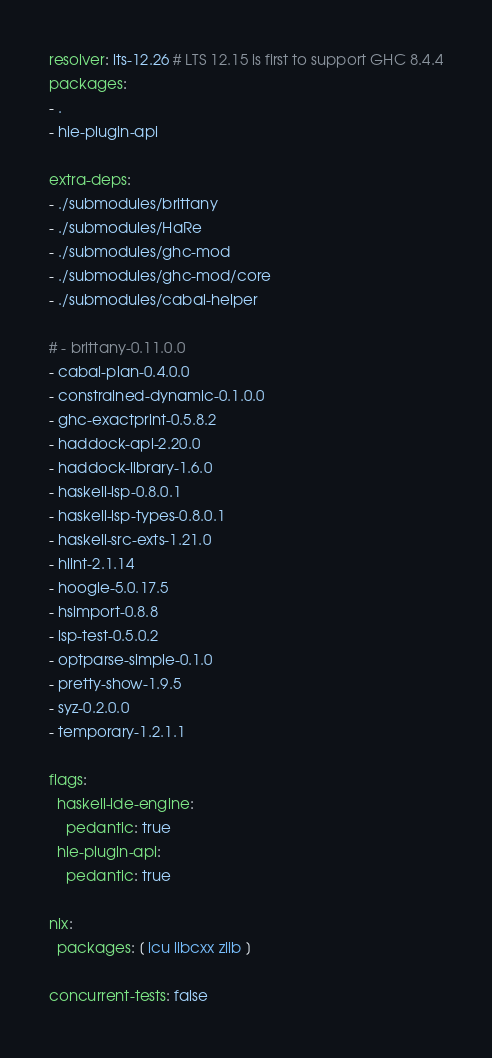Convert code to text. <code><loc_0><loc_0><loc_500><loc_500><_YAML_>resolver: lts-12.26 # LTS 12.15 is first to support GHC 8.4.4
packages:
- .
- hie-plugin-api

extra-deps:
- ./submodules/brittany
- ./submodules/HaRe
- ./submodules/ghc-mod
- ./submodules/ghc-mod/core
- ./submodules/cabal-helper

# - brittany-0.11.0.0
- cabal-plan-0.4.0.0
- constrained-dynamic-0.1.0.0
- ghc-exactprint-0.5.8.2
- haddock-api-2.20.0
- haddock-library-1.6.0
- haskell-lsp-0.8.0.1
- haskell-lsp-types-0.8.0.1
- haskell-src-exts-1.21.0
- hlint-2.1.14
- hoogle-5.0.17.5
- hsimport-0.8.8
- lsp-test-0.5.0.2
- optparse-simple-0.1.0
- pretty-show-1.9.5
- syz-0.2.0.0
- temporary-1.2.1.1

flags:
  haskell-ide-engine:
    pedantic: true
  hie-plugin-api:
    pedantic: true

nix:
  packages: [ icu libcxx zlib ]

concurrent-tests: false
</code> 